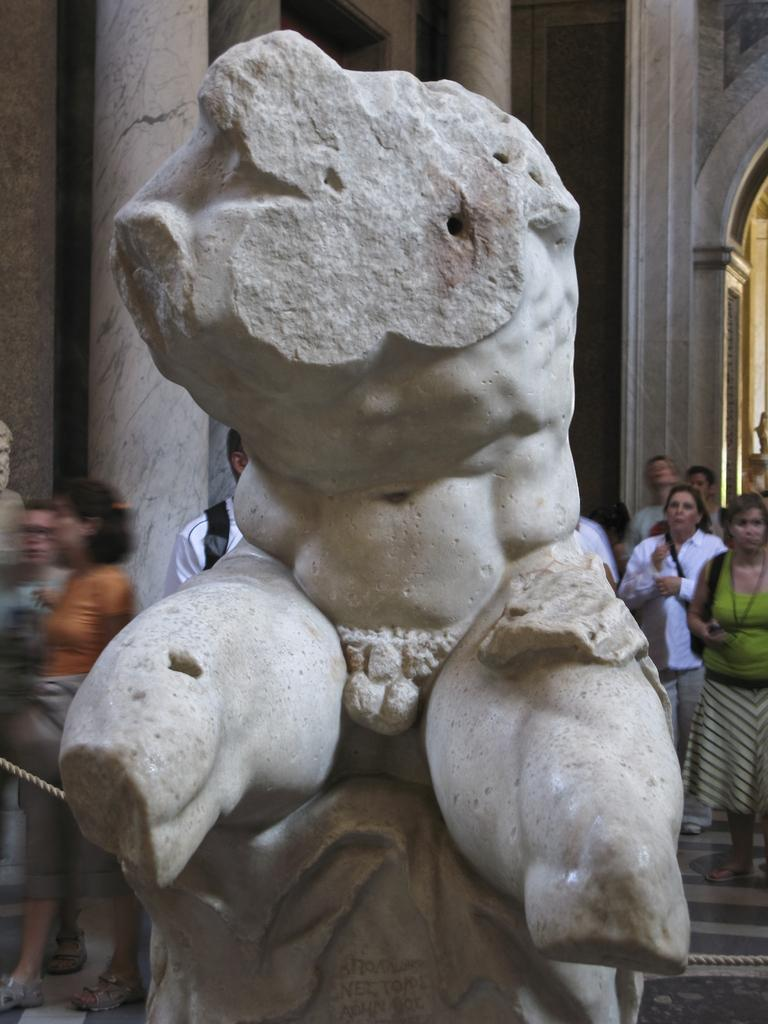What is the main subject in the middle of the picture? There is a statue in the middle of the picture. What else can be seen in the background of the picture? There are people in the background of the picture. What type of fan is being used by the statue in the image? There is no fan present in the image; it features a statue and people in the background. 